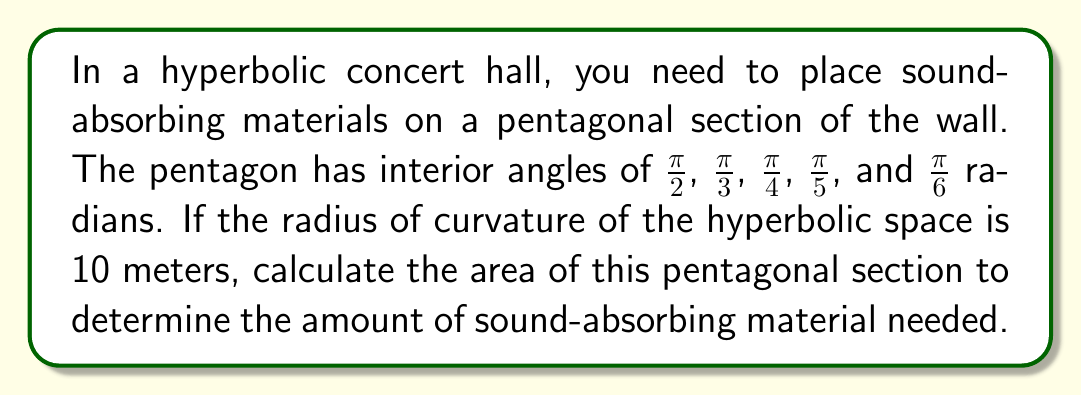Provide a solution to this math problem. To solve this problem, we'll use the Gauss-Bonnet formula for hyperbolic polygons:

$$A = (\sum_{i=1}^n \alpha_i - (n-2)\pi)R^2$$

Where:
$A$ is the area of the polygon
$n$ is the number of sides
$\alpha_i$ are the interior angles
$R$ is the radius of curvature

Step 1: Identify the given information
- Number of sides, $n = 5$
- Interior angles: $\frac{\pi}{2}$, $\frac{\pi}{3}$, $\frac{\pi}{4}$, $\frac{\pi}{5}$, $\frac{\pi}{6}$
- Radius of curvature, $R = 10$ meters

Step 2: Sum the interior angles
$$\sum_{i=1}^n \alpha_i = \frac{\pi}{2} + \frac{\pi}{3} + \frac{\pi}{4} + \frac{\pi}{5} + \frac{\pi}{6}$$
$$= \frac{30\pi + 20\pi + 15\pi + 12\pi + 10\pi}{60}$$
$$= \frac{87\pi}{60}$$

Step 3: Apply the Gauss-Bonnet formula
$$A = (\frac{87\pi}{60} - (5-2)\pi) \cdot 10^2$$
$$= (\frac{87\pi}{60} - 3\pi) \cdot 100$$
$$= (\frac{87\pi - 180\pi}{60}) \cdot 100$$
$$= \frac{-93\pi}{60} \cdot 100$$
$$= -155\pi$$

Step 4: Take the absolute value (since area is always positive)
$$A = 155\pi \approx 486.95 \text{ square meters}$$
Answer: $155\pi \approx 486.95 \text{ m}^2$ 